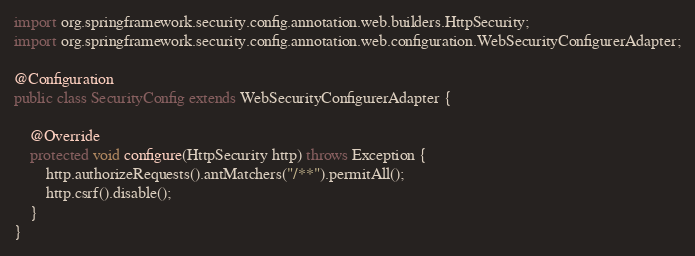<code> <loc_0><loc_0><loc_500><loc_500><_Java_>import org.springframework.security.config.annotation.web.builders.HttpSecurity;
import org.springframework.security.config.annotation.web.configuration.WebSecurityConfigurerAdapter;

@Configuration
public class SecurityConfig extends WebSecurityConfigurerAdapter {

    @Override
    protected void configure(HttpSecurity http) throws Exception {
        http.authorizeRequests().antMatchers("/**").permitAll();
        http.csrf().disable();
    }
}
</code> 